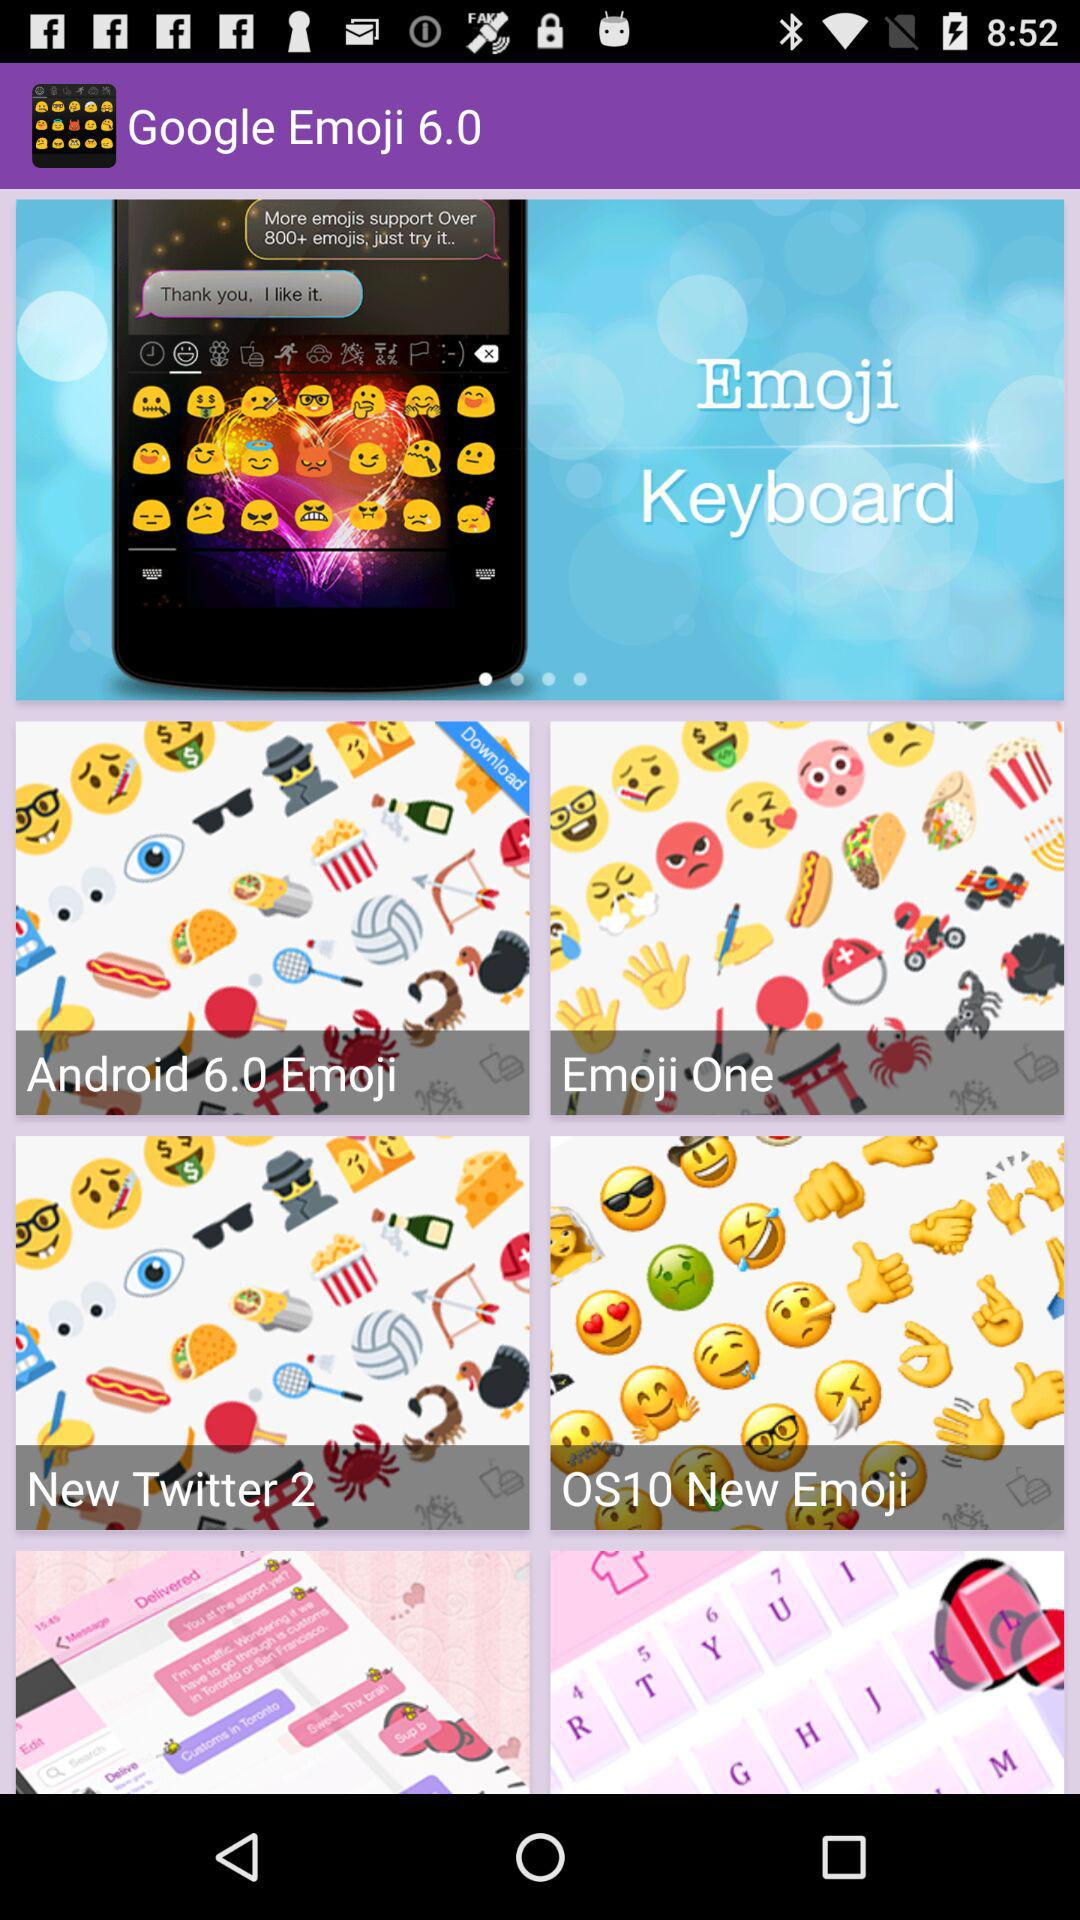What is the application name? The application name is "Google Emoji 6.0". 